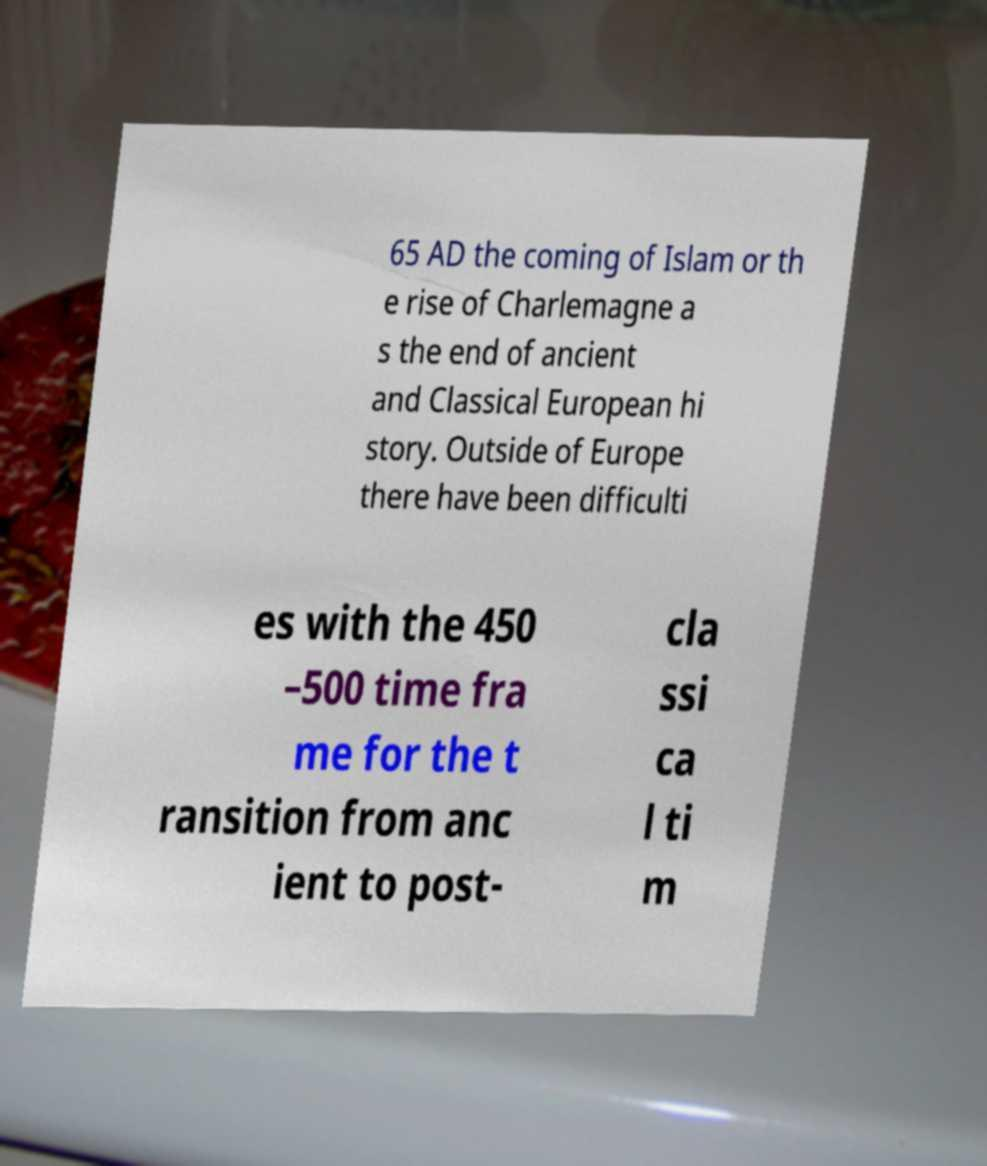Please read and relay the text visible in this image. What does it say? 65 AD the coming of Islam or th e rise of Charlemagne a s the end of ancient and Classical European hi story. Outside of Europe there have been difficulti es with the 450 –500 time fra me for the t ransition from anc ient to post- cla ssi ca l ti m 